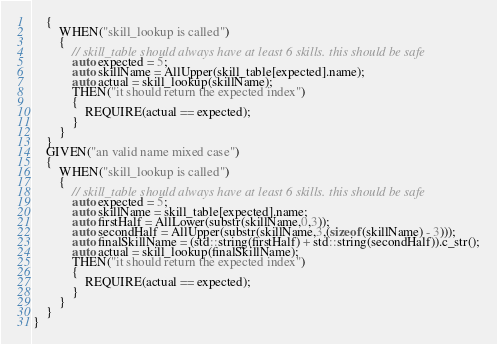Convert code to text. <code><loc_0><loc_0><loc_500><loc_500><_C_>	{
		WHEN("skill_lookup is called")
		{
			// skill_table should always have at least 6 skills. this should be safe
			auto expected = 5;
			auto skillName = AllUpper(skill_table[expected].name); 
			auto actual = skill_lookup(skillName);
			THEN("it should return the expected index")
			{
				REQUIRE(actual == expected);
			}
		}
	}
	GIVEN("an valid name mixed case")
	{
		WHEN("skill_lookup is called")
		{
			// skill_table should always have at least 6 skills. this should be safe
			auto expected = 5;
			auto skillName = skill_table[expected].name; 
			auto firstHalf = AllLower(substr(skillName,0,3));
			auto secondHalf = AllUpper(substr(skillName,3,(sizeof(skillName) - 3)));
			auto finalSkillName = (std::string(firstHalf) + std::string(secondHalf)).c_str();
			auto actual = skill_lookup(finalSkillName);
			THEN("it should return the expected index")
			{
				REQUIRE(actual == expected);
			}
		}
	}
}</code> 